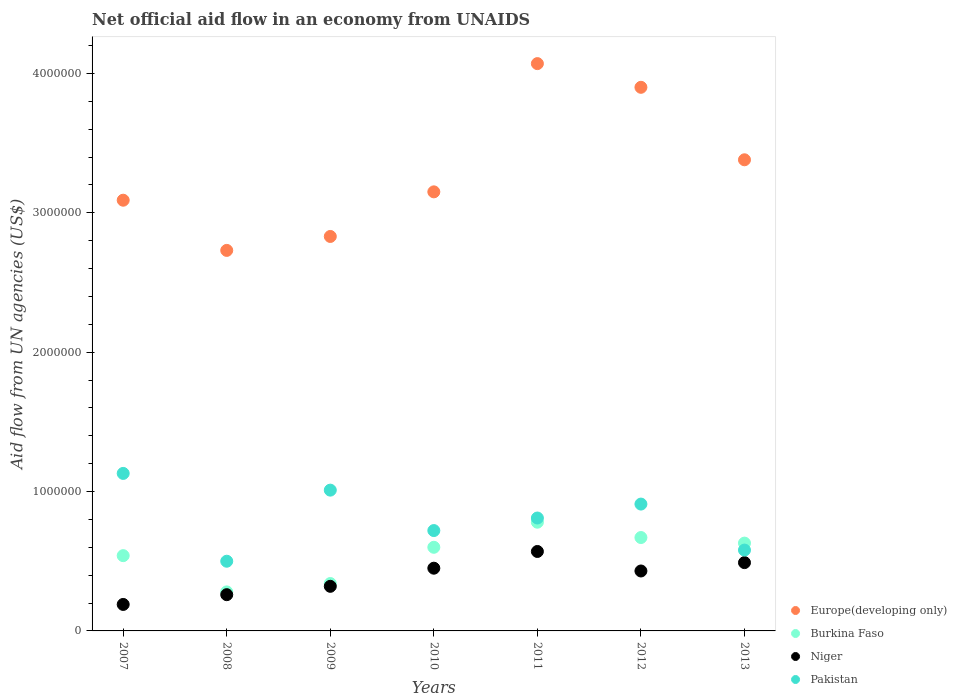What is the net official aid flow in Europe(developing only) in 2007?
Give a very brief answer. 3.09e+06. Across all years, what is the maximum net official aid flow in Europe(developing only)?
Ensure brevity in your answer.  4.07e+06. Across all years, what is the minimum net official aid flow in Niger?
Your answer should be very brief. 1.90e+05. In which year was the net official aid flow in Niger maximum?
Keep it short and to the point. 2011. What is the total net official aid flow in Niger in the graph?
Your response must be concise. 2.71e+06. What is the difference between the net official aid flow in Burkina Faso in 2008 and that in 2011?
Your answer should be compact. -5.00e+05. What is the difference between the net official aid flow in Pakistan in 2011 and the net official aid flow in Burkina Faso in 2012?
Your answer should be compact. 1.40e+05. What is the average net official aid flow in Pakistan per year?
Keep it short and to the point. 8.09e+05. In the year 2007, what is the difference between the net official aid flow in Pakistan and net official aid flow in Niger?
Give a very brief answer. 9.40e+05. What is the ratio of the net official aid flow in Pakistan in 2009 to that in 2011?
Ensure brevity in your answer.  1.25. Is the net official aid flow in Europe(developing only) in 2008 less than that in 2013?
Keep it short and to the point. Yes. What is the difference between the highest and the lowest net official aid flow in Europe(developing only)?
Give a very brief answer. 1.34e+06. In how many years, is the net official aid flow in Europe(developing only) greater than the average net official aid flow in Europe(developing only) taken over all years?
Your answer should be very brief. 3. Is it the case that in every year, the sum of the net official aid flow in Burkina Faso and net official aid flow in Pakistan  is greater than the sum of net official aid flow in Niger and net official aid flow in Europe(developing only)?
Your response must be concise. Yes. Does the net official aid flow in Pakistan monotonically increase over the years?
Provide a succinct answer. No. How many dotlines are there?
Offer a very short reply. 4. What is the difference between two consecutive major ticks on the Y-axis?
Provide a short and direct response. 1.00e+06. Does the graph contain any zero values?
Provide a succinct answer. No. Where does the legend appear in the graph?
Provide a short and direct response. Bottom right. What is the title of the graph?
Your answer should be very brief. Net official aid flow in an economy from UNAIDS. Does "South Africa" appear as one of the legend labels in the graph?
Keep it short and to the point. No. What is the label or title of the Y-axis?
Offer a terse response. Aid flow from UN agencies (US$). What is the Aid flow from UN agencies (US$) of Europe(developing only) in 2007?
Keep it short and to the point. 3.09e+06. What is the Aid flow from UN agencies (US$) of Burkina Faso in 2007?
Keep it short and to the point. 5.40e+05. What is the Aid flow from UN agencies (US$) in Pakistan in 2007?
Ensure brevity in your answer.  1.13e+06. What is the Aid flow from UN agencies (US$) in Europe(developing only) in 2008?
Provide a short and direct response. 2.73e+06. What is the Aid flow from UN agencies (US$) of Europe(developing only) in 2009?
Offer a terse response. 2.83e+06. What is the Aid flow from UN agencies (US$) in Burkina Faso in 2009?
Keep it short and to the point. 3.40e+05. What is the Aid flow from UN agencies (US$) in Niger in 2009?
Offer a terse response. 3.20e+05. What is the Aid flow from UN agencies (US$) of Pakistan in 2009?
Your answer should be very brief. 1.01e+06. What is the Aid flow from UN agencies (US$) in Europe(developing only) in 2010?
Keep it short and to the point. 3.15e+06. What is the Aid flow from UN agencies (US$) in Burkina Faso in 2010?
Your response must be concise. 6.00e+05. What is the Aid flow from UN agencies (US$) of Niger in 2010?
Make the answer very short. 4.50e+05. What is the Aid flow from UN agencies (US$) in Pakistan in 2010?
Offer a very short reply. 7.20e+05. What is the Aid flow from UN agencies (US$) in Europe(developing only) in 2011?
Your response must be concise. 4.07e+06. What is the Aid flow from UN agencies (US$) in Burkina Faso in 2011?
Make the answer very short. 7.80e+05. What is the Aid flow from UN agencies (US$) of Niger in 2011?
Provide a short and direct response. 5.70e+05. What is the Aid flow from UN agencies (US$) in Pakistan in 2011?
Your answer should be compact. 8.10e+05. What is the Aid flow from UN agencies (US$) of Europe(developing only) in 2012?
Offer a very short reply. 3.90e+06. What is the Aid flow from UN agencies (US$) in Burkina Faso in 2012?
Keep it short and to the point. 6.70e+05. What is the Aid flow from UN agencies (US$) of Niger in 2012?
Give a very brief answer. 4.30e+05. What is the Aid flow from UN agencies (US$) in Pakistan in 2012?
Offer a terse response. 9.10e+05. What is the Aid flow from UN agencies (US$) of Europe(developing only) in 2013?
Offer a terse response. 3.38e+06. What is the Aid flow from UN agencies (US$) in Burkina Faso in 2013?
Ensure brevity in your answer.  6.30e+05. What is the Aid flow from UN agencies (US$) of Pakistan in 2013?
Make the answer very short. 5.80e+05. Across all years, what is the maximum Aid flow from UN agencies (US$) in Europe(developing only)?
Keep it short and to the point. 4.07e+06. Across all years, what is the maximum Aid flow from UN agencies (US$) in Burkina Faso?
Give a very brief answer. 7.80e+05. Across all years, what is the maximum Aid flow from UN agencies (US$) in Niger?
Your response must be concise. 5.70e+05. Across all years, what is the maximum Aid flow from UN agencies (US$) of Pakistan?
Offer a very short reply. 1.13e+06. Across all years, what is the minimum Aid flow from UN agencies (US$) in Europe(developing only)?
Provide a short and direct response. 2.73e+06. Across all years, what is the minimum Aid flow from UN agencies (US$) of Niger?
Make the answer very short. 1.90e+05. Across all years, what is the minimum Aid flow from UN agencies (US$) in Pakistan?
Ensure brevity in your answer.  5.00e+05. What is the total Aid flow from UN agencies (US$) in Europe(developing only) in the graph?
Your answer should be compact. 2.32e+07. What is the total Aid flow from UN agencies (US$) in Burkina Faso in the graph?
Offer a terse response. 3.84e+06. What is the total Aid flow from UN agencies (US$) in Niger in the graph?
Your answer should be very brief. 2.71e+06. What is the total Aid flow from UN agencies (US$) in Pakistan in the graph?
Provide a succinct answer. 5.66e+06. What is the difference between the Aid flow from UN agencies (US$) of Burkina Faso in 2007 and that in 2008?
Provide a succinct answer. 2.60e+05. What is the difference between the Aid flow from UN agencies (US$) of Pakistan in 2007 and that in 2008?
Make the answer very short. 6.30e+05. What is the difference between the Aid flow from UN agencies (US$) in Europe(developing only) in 2007 and that in 2009?
Ensure brevity in your answer.  2.60e+05. What is the difference between the Aid flow from UN agencies (US$) of Niger in 2007 and that in 2009?
Give a very brief answer. -1.30e+05. What is the difference between the Aid flow from UN agencies (US$) of Pakistan in 2007 and that in 2009?
Provide a short and direct response. 1.20e+05. What is the difference between the Aid flow from UN agencies (US$) of Europe(developing only) in 2007 and that in 2010?
Offer a very short reply. -6.00e+04. What is the difference between the Aid flow from UN agencies (US$) in Burkina Faso in 2007 and that in 2010?
Make the answer very short. -6.00e+04. What is the difference between the Aid flow from UN agencies (US$) of Europe(developing only) in 2007 and that in 2011?
Offer a very short reply. -9.80e+05. What is the difference between the Aid flow from UN agencies (US$) in Niger in 2007 and that in 2011?
Provide a succinct answer. -3.80e+05. What is the difference between the Aid flow from UN agencies (US$) in Europe(developing only) in 2007 and that in 2012?
Give a very brief answer. -8.10e+05. What is the difference between the Aid flow from UN agencies (US$) in Niger in 2007 and that in 2012?
Make the answer very short. -2.40e+05. What is the difference between the Aid flow from UN agencies (US$) in Pakistan in 2007 and that in 2012?
Ensure brevity in your answer.  2.20e+05. What is the difference between the Aid flow from UN agencies (US$) in Europe(developing only) in 2007 and that in 2013?
Ensure brevity in your answer.  -2.90e+05. What is the difference between the Aid flow from UN agencies (US$) of Pakistan in 2007 and that in 2013?
Provide a succinct answer. 5.50e+05. What is the difference between the Aid flow from UN agencies (US$) in Europe(developing only) in 2008 and that in 2009?
Ensure brevity in your answer.  -1.00e+05. What is the difference between the Aid flow from UN agencies (US$) in Pakistan in 2008 and that in 2009?
Ensure brevity in your answer.  -5.10e+05. What is the difference between the Aid flow from UN agencies (US$) in Europe(developing only) in 2008 and that in 2010?
Your answer should be very brief. -4.20e+05. What is the difference between the Aid flow from UN agencies (US$) in Burkina Faso in 2008 and that in 2010?
Make the answer very short. -3.20e+05. What is the difference between the Aid flow from UN agencies (US$) of Europe(developing only) in 2008 and that in 2011?
Offer a terse response. -1.34e+06. What is the difference between the Aid flow from UN agencies (US$) in Burkina Faso in 2008 and that in 2011?
Offer a very short reply. -5.00e+05. What is the difference between the Aid flow from UN agencies (US$) in Niger in 2008 and that in 2011?
Offer a very short reply. -3.10e+05. What is the difference between the Aid flow from UN agencies (US$) in Pakistan in 2008 and that in 2011?
Make the answer very short. -3.10e+05. What is the difference between the Aid flow from UN agencies (US$) in Europe(developing only) in 2008 and that in 2012?
Provide a short and direct response. -1.17e+06. What is the difference between the Aid flow from UN agencies (US$) in Burkina Faso in 2008 and that in 2012?
Keep it short and to the point. -3.90e+05. What is the difference between the Aid flow from UN agencies (US$) in Niger in 2008 and that in 2012?
Your response must be concise. -1.70e+05. What is the difference between the Aid flow from UN agencies (US$) of Pakistan in 2008 and that in 2012?
Offer a very short reply. -4.10e+05. What is the difference between the Aid flow from UN agencies (US$) of Europe(developing only) in 2008 and that in 2013?
Provide a short and direct response. -6.50e+05. What is the difference between the Aid flow from UN agencies (US$) of Burkina Faso in 2008 and that in 2013?
Your answer should be compact. -3.50e+05. What is the difference between the Aid flow from UN agencies (US$) in Pakistan in 2008 and that in 2013?
Give a very brief answer. -8.00e+04. What is the difference between the Aid flow from UN agencies (US$) in Europe(developing only) in 2009 and that in 2010?
Your response must be concise. -3.20e+05. What is the difference between the Aid flow from UN agencies (US$) of Burkina Faso in 2009 and that in 2010?
Offer a very short reply. -2.60e+05. What is the difference between the Aid flow from UN agencies (US$) of Niger in 2009 and that in 2010?
Make the answer very short. -1.30e+05. What is the difference between the Aid flow from UN agencies (US$) in Pakistan in 2009 and that in 2010?
Ensure brevity in your answer.  2.90e+05. What is the difference between the Aid flow from UN agencies (US$) in Europe(developing only) in 2009 and that in 2011?
Make the answer very short. -1.24e+06. What is the difference between the Aid flow from UN agencies (US$) of Burkina Faso in 2009 and that in 2011?
Your answer should be very brief. -4.40e+05. What is the difference between the Aid flow from UN agencies (US$) of Europe(developing only) in 2009 and that in 2012?
Offer a very short reply. -1.07e+06. What is the difference between the Aid flow from UN agencies (US$) of Burkina Faso in 2009 and that in 2012?
Your answer should be compact. -3.30e+05. What is the difference between the Aid flow from UN agencies (US$) of Pakistan in 2009 and that in 2012?
Ensure brevity in your answer.  1.00e+05. What is the difference between the Aid flow from UN agencies (US$) of Europe(developing only) in 2009 and that in 2013?
Provide a succinct answer. -5.50e+05. What is the difference between the Aid flow from UN agencies (US$) of Burkina Faso in 2009 and that in 2013?
Your response must be concise. -2.90e+05. What is the difference between the Aid flow from UN agencies (US$) in Europe(developing only) in 2010 and that in 2011?
Offer a very short reply. -9.20e+05. What is the difference between the Aid flow from UN agencies (US$) of Pakistan in 2010 and that in 2011?
Give a very brief answer. -9.00e+04. What is the difference between the Aid flow from UN agencies (US$) of Europe(developing only) in 2010 and that in 2012?
Make the answer very short. -7.50e+05. What is the difference between the Aid flow from UN agencies (US$) in Burkina Faso in 2010 and that in 2012?
Keep it short and to the point. -7.00e+04. What is the difference between the Aid flow from UN agencies (US$) in Niger in 2010 and that in 2012?
Offer a terse response. 2.00e+04. What is the difference between the Aid flow from UN agencies (US$) in Niger in 2010 and that in 2013?
Offer a terse response. -4.00e+04. What is the difference between the Aid flow from UN agencies (US$) of Pakistan in 2010 and that in 2013?
Make the answer very short. 1.40e+05. What is the difference between the Aid flow from UN agencies (US$) of Burkina Faso in 2011 and that in 2012?
Offer a very short reply. 1.10e+05. What is the difference between the Aid flow from UN agencies (US$) in Niger in 2011 and that in 2012?
Keep it short and to the point. 1.40e+05. What is the difference between the Aid flow from UN agencies (US$) in Europe(developing only) in 2011 and that in 2013?
Keep it short and to the point. 6.90e+05. What is the difference between the Aid flow from UN agencies (US$) of Burkina Faso in 2011 and that in 2013?
Your response must be concise. 1.50e+05. What is the difference between the Aid flow from UN agencies (US$) of Pakistan in 2011 and that in 2013?
Your answer should be compact. 2.30e+05. What is the difference between the Aid flow from UN agencies (US$) of Europe(developing only) in 2012 and that in 2013?
Offer a terse response. 5.20e+05. What is the difference between the Aid flow from UN agencies (US$) of Burkina Faso in 2012 and that in 2013?
Keep it short and to the point. 4.00e+04. What is the difference between the Aid flow from UN agencies (US$) of Niger in 2012 and that in 2013?
Your answer should be very brief. -6.00e+04. What is the difference between the Aid flow from UN agencies (US$) in Pakistan in 2012 and that in 2013?
Your response must be concise. 3.30e+05. What is the difference between the Aid flow from UN agencies (US$) of Europe(developing only) in 2007 and the Aid flow from UN agencies (US$) of Burkina Faso in 2008?
Your answer should be compact. 2.81e+06. What is the difference between the Aid flow from UN agencies (US$) of Europe(developing only) in 2007 and the Aid flow from UN agencies (US$) of Niger in 2008?
Provide a short and direct response. 2.83e+06. What is the difference between the Aid flow from UN agencies (US$) in Europe(developing only) in 2007 and the Aid flow from UN agencies (US$) in Pakistan in 2008?
Offer a terse response. 2.59e+06. What is the difference between the Aid flow from UN agencies (US$) of Burkina Faso in 2007 and the Aid flow from UN agencies (US$) of Niger in 2008?
Your response must be concise. 2.80e+05. What is the difference between the Aid flow from UN agencies (US$) in Burkina Faso in 2007 and the Aid flow from UN agencies (US$) in Pakistan in 2008?
Give a very brief answer. 4.00e+04. What is the difference between the Aid flow from UN agencies (US$) in Niger in 2007 and the Aid flow from UN agencies (US$) in Pakistan in 2008?
Keep it short and to the point. -3.10e+05. What is the difference between the Aid flow from UN agencies (US$) in Europe(developing only) in 2007 and the Aid flow from UN agencies (US$) in Burkina Faso in 2009?
Your answer should be compact. 2.75e+06. What is the difference between the Aid flow from UN agencies (US$) in Europe(developing only) in 2007 and the Aid flow from UN agencies (US$) in Niger in 2009?
Provide a short and direct response. 2.77e+06. What is the difference between the Aid flow from UN agencies (US$) of Europe(developing only) in 2007 and the Aid flow from UN agencies (US$) of Pakistan in 2009?
Offer a very short reply. 2.08e+06. What is the difference between the Aid flow from UN agencies (US$) of Burkina Faso in 2007 and the Aid flow from UN agencies (US$) of Pakistan in 2009?
Offer a terse response. -4.70e+05. What is the difference between the Aid flow from UN agencies (US$) in Niger in 2007 and the Aid flow from UN agencies (US$) in Pakistan in 2009?
Provide a short and direct response. -8.20e+05. What is the difference between the Aid flow from UN agencies (US$) of Europe(developing only) in 2007 and the Aid flow from UN agencies (US$) of Burkina Faso in 2010?
Make the answer very short. 2.49e+06. What is the difference between the Aid flow from UN agencies (US$) of Europe(developing only) in 2007 and the Aid flow from UN agencies (US$) of Niger in 2010?
Your answer should be very brief. 2.64e+06. What is the difference between the Aid flow from UN agencies (US$) in Europe(developing only) in 2007 and the Aid flow from UN agencies (US$) in Pakistan in 2010?
Offer a terse response. 2.37e+06. What is the difference between the Aid flow from UN agencies (US$) of Burkina Faso in 2007 and the Aid flow from UN agencies (US$) of Pakistan in 2010?
Your answer should be very brief. -1.80e+05. What is the difference between the Aid flow from UN agencies (US$) of Niger in 2007 and the Aid flow from UN agencies (US$) of Pakistan in 2010?
Make the answer very short. -5.30e+05. What is the difference between the Aid flow from UN agencies (US$) of Europe(developing only) in 2007 and the Aid flow from UN agencies (US$) of Burkina Faso in 2011?
Ensure brevity in your answer.  2.31e+06. What is the difference between the Aid flow from UN agencies (US$) in Europe(developing only) in 2007 and the Aid flow from UN agencies (US$) in Niger in 2011?
Give a very brief answer. 2.52e+06. What is the difference between the Aid flow from UN agencies (US$) of Europe(developing only) in 2007 and the Aid flow from UN agencies (US$) of Pakistan in 2011?
Offer a very short reply. 2.28e+06. What is the difference between the Aid flow from UN agencies (US$) in Burkina Faso in 2007 and the Aid flow from UN agencies (US$) in Pakistan in 2011?
Your answer should be compact. -2.70e+05. What is the difference between the Aid flow from UN agencies (US$) of Niger in 2007 and the Aid flow from UN agencies (US$) of Pakistan in 2011?
Keep it short and to the point. -6.20e+05. What is the difference between the Aid flow from UN agencies (US$) in Europe(developing only) in 2007 and the Aid flow from UN agencies (US$) in Burkina Faso in 2012?
Provide a short and direct response. 2.42e+06. What is the difference between the Aid flow from UN agencies (US$) in Europe(developing only) in 2007 and the Aid flow from UN agencies (US$) in Niger in 2012?
Your answer should be compact. 2.66e+06. What is the difference between the Aid flow from UN agencies (US$) of Europe(developing only) in 2007 and the Aid flow from UN agencies (US$) of Pakistan in 2012?
Provide a short and direct response. 2.18e+06. What is the difference between the Aid flow from UN agencies (US$) of Burkina Faso in 2007 and the Aid flow from UN agencies (US$) of Niger in 2012?
Your response must be concise. 1.10e+05. What is the difference between the Aid flow from UN agencies (US$) in Burkina Faso in 2007 and the Aid flow from UN agencies (US$) in Pakistan in 2012?
Offer a terse response. -3.70e+05. What is the difference between the Aid flow from UN agencies (US$) in Niger in 2007 and the Aid flow from UN agencies (US$) in Pakistan in 2012?
Your response must be concise. -7.20e+05. What is the difference between the Aid flow from UN agencies (US$) in Europe(developing only) in 2007 and the Aid flow from UN agencies (US$) in Burkina Faso in 2013?
Provide a short and direct response. 2.46e+06. What is the difference between the Aid flow from UN agencies (US$) of Europe(developing only) in 2007 and the Aid flow from UN agencies (US$) of Niger in 2013?
Provide a short and direct response. 2.60e+06. What is the difference between the Aid flow from UN agencies (US$) in Europe(developing only) in 2007 and the Aid flow from UN agencies (US$) in Pakistan in 2013?
Offer a very short reply. 2.51e+06. What is the difference between the Aid flow from UN agencies (US$) of Burkina Faso in 2007 and the Aid flow from UN agencies (US$) of Pakistan in 2013?
Provide a succinct answer. -4.00e+04. What is the difference between the Aid flow from UN agencies (US$) in Niger in 2007 and the Aid flow from UN agencies (US$) in Pakistan in 2013?
Your answer should be compact. -3.90e+05. What is the difference between the Aid flow from UN agencies (US$) in Europe(developing only) in 2008 and the Aid flow from UN agencies (US$) in Burkina Faso in 2009?
Your answer should be very brief. 2.39e+06. What is the difference between the Aid flow from UN agencies (US$) of Europe(developing only) in 2008 and the Aid flow from UN agencies (US$) of Niger in 2009?
Offer a terse response. 2.41e+06. What is the difference between the Aid flow from UN agencies (US$) of Europe(developing only) in 2008 and the Aid flow from UN agencies (US$) of Pakistan in 2009?
Offer a very short reply. 1.72e+06. What is the difference between the Aid flow from UN agencies (US$) of Burkina Faso in 2008 and the Aid flow from UN agencies (US$) of Pakistan in 2009?
Ensure brevity in your answer.  -7.30e+05. What is the difference between the Aid flow from UN agencies (US$) in Niger in 2008 and the Aid flow from UN agencies (US$) in Pakistan in 2009?
Ensure brevity in your answer.  -7.50e+05. What is the difference between the Aid flow from UN agencies (US$) in Europe(developing only) in 2008 and the Aid flow from UN agencies (US$) in Burkina Faso in 2010?
Make the answer very short. 2.13e+06. What is the difference between the Aid flow from UN agencies (US$) of Europe(developing only) in 2008 and the Aid flow from UN agencies (US$) of Niger in 2010?
Provide a short and direct response. 2.28e+06. What is the difference between the Aid flow from UN agencies (US$) in Europe(developing only) in 2008 and the Aid flow from UN agencies (US$) in Pakistan in 2010?
Your response must be concise. 2.01e+06. What is the difference between the Aid flow from UN agencies (US$) of Burkina Faso in 2008 and the Aid flow from UN agencies (US$) of Niger in 2010?
Provide a short and direct response. -1.70e+05. What is the difference between the Aid flow from UN agencies (US$) in Burkina Faso in 2008 and the Aid flow from UN agencies (US$) in Pakistan in 2010?
Offer a very short reply. -4.40e+05. What is the difference between the Aid flow from UN agencies (US$) in Niger in 2008 and the Aid flow from UN agencies (US$) in Pakistan in 2010?
Your answer should be compact. -4.60e+05. What is the difference between the Aid flow from UN agencies (US$) of Europe(developing only) in 2008 and the Aid flow from UN agencies (US$) of Burkina Faso in 2011?
Make the answer very short. 1.95e+06. What is the difference between the Aid flow from UN agencies (US$) of Europe(developing only) in 2008 and the Aid flow from UN agencies (US$) of Niger in 2011?
Keep it short and to the point. 2.16e+06. What is the difference between the Aid flow from UN agencies (US$) in Europe(developing only) in 2008 and the Aid flow from UN agencies (US$) in Pakistan in 2011?
Ensure brevity in your answer.  1.92e+06. What is the difference between the Aid flow from UN agencies (US$) in Burkina Faso in 2008 and the Aid flow from UN agencies (US$) in Niger in 2011?
Make the answer very short. -2.90e+05. What is the difference between the Aid flow from UN agencies (US$) in Burkina Faso in 2008 and the Aid flow from UN agencies (US$) in Pakistan in 2011?
Offer a very short reply. -5.30e+05. What is the difference between the Aid flow from UN agencies (US$) of Niger in 2008 and the Aid flow from UN agencies (US$) of Pakistan in 2011?
Offer a very short reply. -5.50e+05. What is the difference between the Aid flow from UN agencies (US$) in Europe(developing only) in 2008 and the Aid flow from UN agencies (US$) in Burkina Faso in 2012?
Your answer should be compact. 2.06e+06. What is the difference between the Aid flow from UN agencies (US$) of Europe(developing only) in 2008 and the Aid flow from UN agencies (US$) of Niger in 2012?
Your response must be concise. 2.30e+06. What is the difference between the Aid flow from UN agencies (US$) of Europe(developing only) in 2008 and the Aid flow from UN agencies (US$) of Pakistan in 2012?
Provide a succinct answer. 1.82e+06. What is the difference between the Aid flow from UN agencies (US$) in Burkina Faso in 2008 and the Aid flow from UN agencies (US$) in Niger in 2012?
Provide a succinct answer. -1.50e+05. What is the difference between the Aid flow from UN agencies (US$) of Burkina Faso in 2008 and the Aid flow from UN agencies (US$) of Pakistan in 2012?
Your answer should be very brief. -6.30e+05. What is the difference between the Aid flow from UN agencies (US$) of Niger in 2008 and the Aid flow from UN agencies (US$) of Pakistan in 2012?
Provide a short and direct response. -6.50e+05. What is the difference between the Aid flow from UN agencies (US$) in Europe(developing only) in 2008 and the Aid flow from UN agencies (US$) in Burkina Faso in 2013?
Ensure brevity in your answer.  2.10e+06. What is the difference between the Aid flow from UN agencies (US$) in Europe(developing only) in 2008 and the Aid flow from UN agencies (US$) in Niger in 2013?
Make the answer very short. 2.24e+06. What is the difference between the Aid flow from UN agencies (US$) in Europe(developing only) in 2008 and the Aid flow from UN agencies (US$) in Pakistan in 2013?
Provide a succinct answer. 2.15e+06. What is the difference between the Aid flow from UN agencies (US$) in Niger in 2008 and the Aid flow from UN agencies (US$) in Pakistan in 2013?
Provide a short and direct response. -3.20e+05. What is the difference between the Aid flow from UN agencies (US$) of Europe(developing only) in 2009 and the Aid flow from UN agencies (US$) of Burkina Faso in 2010?
Make the answer very short. 2.23e+06. What is the difference between the Aid flow from UN agencies (US$) in Europe(developing only) in 2009 and the Aid flow from UN agencies (US$) in Niger in 2010?
Provide a succinct answer. 2.38e+06. What is the difference between the Aid flow from UN agencies (US$) of Europe(developing only) in 2009 and the Aid flow from UN agencies (US$) of Pakistan in 2010?
Give a very brief answer. 2.11e+06. What is the difference between the Aid flow from UN agencies (US$) in Burkina Faso in 2009 and the Aid flow from UN agencies (US$) in Pakistan in 2010?
Your response must be concise. -3.80e+05. What is the difference between the Aid flow from UN agencies (US$) of Niger in 2009 and the Aid flow from UN agencies (US$) of Pakistan in 2010?
Your response must be concise. -4.00e+05. What is the difference between the Aid flow from UN agencies (US$) in Europe(developing only) in 2009 and the Aid flow from UN agencies (US$) in Burkina Faso in 2011?
Offer a terse response. 2.05e+06. What is the difference between the Aid flow from UN agencies (US$) of Europe(developing only) in 2009 and the Aid flow from UN agencies (US$) of Niger in 2011?
Ensure brevity in your answer.  2.26e+06. What is the difference between the Aid flow from UN agencies (US$) in Europe(developing only) in 2009 and the Aid flow from UN agencies (US$) in Pakistan in 2011?
Offer a very short reply. 2.02e+06. What is the difference between the Aid flow from UN agencies (US$) in Burkina Faso in 2009 and the Aid flow from UN agencies (US$) in Niger in 2011?
Your answer should be compact. -2.30e+05. What is the difference between the Aid flow from UN agencies (US$) of Burkina Faso in 2009 and the Aid flow from UN agencies (US$) of Pakistan in 2011?
Your response must be concise. -4.70e+05. What is the difference between the Aid flow from UN agencies (US$) of Niger in 2009 and the Aid flow from UN agencies (US$) of Pakistan in 2011?
Provide a short and direct response. -4.90e+05. What is the difference between the Aid flow from UN agencies (US$) of Europe(developing only) in 2009 and the Aid flow from UN agencies (US$) of Burkina Faso in 2012?
Keep it short and to the point. 2.16e+06. What is the difference between the Aid flow from UN agencies (US$) of Europe(developing only) in 2009 and the Aid flow from UN agencies (US$) of Niger in 2012?
Make the answer very short. 2.40e+06. What is the difference between the Aid flow from UN agencies (US$) of Europe(developing only) in 2009 and the Aid flow from UN agencies (US$) of Pakistan in 2012?
Your answer should be compact. 1.92e+06. What is the difference between the Aid flow from UN agencies (US$) of Burkina Faso in 2009 and the Aid flow from UN agencies (US$) of Pakistan in 2012?
Provide a succinct answer. -5.70e+05. What is the difference between the Aid flow from UN agencies (US$) in Niger in 2009 and the Aid flow from UN agencies (US$) in Pakistan in 2012?
Give a very brief answer. -5.90e+05. What is the difference between the Aid flow from UN agencies (US$) in Europe(developing only) in 2009 and the Aid flow from UN agencies (US$) in Burkina Faso in 2013?
Give a very brief answer. 2.20e+06. What is the difference between the Aid flow from UN agencies (US$) of Europe(developing only) in 2009 and the Aid flow from UN agencies (US$) of Niger in 2013?
Make the answer very short. 2.34e+06. What is the difference between the Aid flow from UN agencies (US$) of Europe(developing only) in 2009 and the Aid flow from UN agencies (US$) of Pakistan in 2013?
Provide a succinct answer. 2.25e+06. What is the difference between the Aid flow from UN agencies (US$) in Niger in 2009 and the Aid flow from UN agencies (US$) in Pakistan in 2013?
Offer a very short reply. -2.60e+05. What is the difference between the Aid flow from UN agencies (US$) of Europe(developing only) in 2010 and the Aid flow from UN agencies (US$) of Burkina Faso in 2011?
Offer a terse response. 2.37e+06. What is the difference between the Aid flow from UN agencies (US$) in Europe(developing only) in 2010 and the Aid flow from UN agencies (US$) in Niger in 2011?
Make the answer very short. 2.58e+06. What is the difference between the Aid flow from UN agencies (US$) in Europe(developing only) in 2010 and the Aid flow from UN agencies (US$) in Pakistan in 2011?
Your answer should be very brief. 2.34e+06. What is the difference between the Aid flow from UN agencies (US$) in Burkina Faso in 2010 and the Aid flow from UN agencies (US$) in Pakistan in 2011?
Offer a terse response. -2.10e+05. What is the difference between the Aid flow from UN agencies (US$) of Niger in 2010 and the Aid flow from UN agencies (US$) of Pakistan in 2011?
Provide a succinct answer. -3.60e+05. What is the difference between the Aid flow from UN agencies (US$) of Europe(developing only) in 2010 and the Aid flow from UN agencies (US$) of Burkina Faso in 2012?
Your response must be concise. 2.48e+06. What is the difference between the Aid flow from UN agencies (US$) in Europe(developing only) in 2010 and the Aid flow from UN agencies (US$) in Niger in 2012?
Make the answer very short. 2.72e+06. What is the difference between the Aid flow from UN agencies (US$) of Europe(developing only) in 2010 and the Aid flow from UN agencies (US$) of Pakistan in 2012?
Provide a succinct answer. 2.24e+06. What is the difference between the Aid flow from UN agencies (US$) in Burkina Faso in 2010 and the Aid flow from UN agencies (US$) in Pakistan in 2012?
Your answer should be very brief. -3.10e+05. What is the difference between the Aid flow from UN agencies (US$) of Niger in 2010 and the Aid flow from UN agencies (US$) of Pakistan in 2012?
Provide a short and direct response. -4.60e+05. What is the difference between the Aid flow from UN agencies (US$) in Europe(developing only) in 2010 and the Aid flow from UN agencies (US$) in Burkina Faso in 2013?
Provide a succinct answer. 2.52e+06. What is the difference between the Aid flow from UN agencies (US$) of Europe(developing only) in 2010 and the Aid flow from UN agencies (US$) of Niger in 2013?
Provide a short and direct response. 2.66e+06. What is the difference between the Aid flow from UN agencies (US$) of Europe(developing only) in 2010 and the Aid flow from UN agencies (US$) of Pakistan in 2013?
Offer a terse response. 2.57e+06. What is the difference between the Aid flow from UN agencies (US$) of Niger in 2010 and the Aid flow from UN agencies (US$) of Pakistan in 2013?
Provide a short and direct response. -1.30e+05. What is the difference between the Aid flow from UN agencies (US$) of Europe(developing only) in 2011 and the Aid flow from UN agencies (US$) of Burkina Faso in 2012?
Keep it short and to the point. 3.40e+06. What is the difference between the Aid flow from UN agencies (US$) of Europe(developing only) in 2011 and the Aid flow from UN agencies (US$) of Niger in 2012?
Provide a succinct answer. 3.64e+06. What is the difference between the Aid flow from UN agencies (US$) in Europe(developing only) in 2011 and the Aid flow from UN agencies (US$) in Pakistan in 2012?
Make the answer very short. 3.16e+06. What is the difference between the Aid flow from UN agencies (US$) in Europe(developing only) in 2011 and the Aid flow from UN agencies (US$) in Burkina Faso in 2013?
Your response must be concise. 3.44e+06. What is the difference between the Aid flow from UN agencies (US$) of Europe(developing only) in 2011 and the Aid flow from UN agencies (US$) of Niger in 2013?
Your answer should be very brief. 3.58e+06. What is the difference between the Aid flow from UN agencies (US$) in Europe(developing only) in 2011 and the Aid flow from UN agencies (US$) in Pakistan in 2013?
Your answer should be compact. 3.49e+06. What is the difference between the Aid flow from UN agencies (US$) in Europe(developing only) in 2012 and the Aid flow from UN agencies (US$) in Burkina Faso in 2013?
Keep it short and to the point. 3.27e+06. What is the difference between the Aid flow from UN agencies (US$) of Europe(developing only) in 2012 and the Aid flow from UN agencies (US$) of Niger in 2013?
Provide a short and direct response. 3.41e+06. What is the difference between the Aid flow from UN agencies (US$) of Europe(developing only) in 2012 and the Aid flow from UN agencies (US$) of Pakistan in 2013?
Offer a terse response. 3.32e+06. What is the difference between the Aid flow from UN agencies (US$) of Burkina Faso in 2012 and the Aid flow from UN agencies (US$) of Niger in 2013?
Make the answer very short. 1.80e+05. What is the average Aid flow from UN agencies (US$) in Europe(developing only) per year?
Provide a succinct answer. 3.31e+06. What is the average Aid flow from UN agencies (US$) of Burkina Faso per year?
Ensure brevity in your answer.  5.49e+05. What is the average Aid flow from UN agencies (US$) in Niger per year?
Your answer should be compact. 3.87e+05. What is the average Aid flow from UN agencies (US$) in Pakistan per year?
Make the answer very short. 8.09e+05. In the year 2007, what is the difference between the Aid flow from UN agencies (US$) in Europe(developing only) and Aid flow from UN agencies (US$) in Burkina Faso?
Keep it short and to the point. 2.55e+06. In the year 2007, what is the difference between the Aid flow from UN agencies (US$) of Europe(developing only) and Aid flow from UN agencies (US$) of Niger?
Offer a terse response. 2.90e+06. In the year 2007, what is the difference between the Aid flow from UN agencies (US$) of Europe(developing only) and Aid flow from UN agencies (US$) of Pakistan?
Provide a succinct answer. 1.96e+06. In the year 2007, what is the difference between the Aid flow from UN agencies (US$) in Burkina Faso and Aid flow from UN agencies (US$) in Niger?
Offer a very short reply. 3.50e+05. In the year 2007, what is the difference between the Aid flow from UN agencies (US$) in Burkina Faso and Aid flow from UN agencies (US$) in Pakistan?
Keep it short and to the point. -5.90e+05. In the year 2007, what is the difference between the Aid flow from UN agencies (US$) of Niger and Aid flow from UN agencies (US$) of Pakistan?
Offer a very short reply. -9.40e+05. In the year 2008, what is the difference between the Aid flow from UN agencies (US$) of Europe(developing only) and Aid flow from UN agencies (US$) of Burkina Faso?
Offer a very short reply. 2.45e+06. In the year 2008, what is the difference between the Aid flow from UN agencies (US$) in Europe(developing only) and Aid flow from UN agencies (US$) in Niger?
Your response must be concise. 2.47e+06. In the year 2008, what is the difference between the Aid flow from UN agencies (US$) of Europe(developing only) and Aid flow from UN agencies (US$) of Pakistan?
Offer a terse response. 2.23e+06. In the year 2008, what is the difference between the Aid flow from UN agencies (US$) in Burkina Faso and Aid flow from UN agencies (US$) in Niger?
Give a very brief answer. 2.00e+04. In the year 2008, what is the difference between the Aid flow from UN agencies (US$) of Niger and Aid flow from UN agencies (US$) of Pakistan?
Your answer should be very brief. -2.40e+05. In the year 2009, what is the difference between the Aid flow from UN agencies (US$) of Europe(developing only) and Aid flow from UN agencies (US$) of Burkina Faso?
Your answer should be compact. 2.49e+06. In the year 2009, what is the difference between the Aid flow from UN agencies (US$) in Europe(developing only) and Aid flow from UN agencies (US$) in Niger?
Provide a short and direct response. 2.51e+06. In the year 2009, what is the difference between the Aid flow from UN agencies (US$) of Europe(developing only) and Aid flow from UN agencies (US$) of Pakistan?
Offer a very short reply. 1.82e+06. In the year 2009, what is the difference between the Aid flow from UN agencies (US$) in Burkina Faso and Aid flow from UN agencies (US$) in Niger?
Your answer should be very brief. 2.00e+04. In the year 2009, what is the difference between the Aid flow from UN agencies (US$) of Burkina Faso and Aid flow from UN agencies (US$) of Pakistan?
Provide a succinct answer. -6.70e+05. In the year 2009, what is the difference between the Aid flow from UN agencies (US$) in Niger and Aid flow from UN agencies (US$) in Pakistan?
Provide a short and direct response. -6.90e+05. In the year 2010, what is the difference between the Aid flow from UN agencies (US$) in Europe(developing only) and Aid flow from UN agencies (US$) in Burkina Faso?
Ensure brevity in your answer.  2.55e+06. In the year 2010, what is the difference between the Aid flow from UN agencies (US$) of Europe(developing only) and Aid flow from UN agencies (US$) of Niger?
Keep it short and to the point. 2.70e+06. In the year 2010, what is the difference between the Aid flow from UN agencies (US$) of Europe(developing only) and Aid flow from UN agencies (US$) of Pakistan?
Ensure brevity in your answer.  2.43e+06. In the year 2010, what is the difference between the Aid flow from UN agencies (US$) in Burkina Faso and Aid flow from UN agencies (US$) in Niger?
Give a very brief answer. 1.50e+05. In the year 2010, what is the difference between the Aid flow from UN agencies (US$) of Niger and Aid flow from UN agencies (US$) of Pakistan?
Provide a short and direct response. -2.70e+05. In the year 2011, what is the difference between the Aid flow from UN agencies (US$) in Europe(developing only) and Aid flow from UN agencies (US$) in Burkina Faso?
Ensure brevity in your answer.  3.29e+06. In the year 2011, what is the difference between the Aid flow from UN agencies (US$) in Europe(developing only) and Aid flow from UN agencies (US$) in Niger?
Provide a short and direct response. 3.50e+06. In the year 2011, what is the difference between the Aid flow from UN agencies (US$) of Europe(developing only) and Aid flow from UN agencies (US$) of Pakistan?
Ensure brevity in your answer.  3.26e+06. In the year 2011, what is the difference between the Aid flow from UN agencies (US$) of Burkina Faso and Aid flow from UN agencies (US$) of Niger?
Keep it short and to the point. 2.10e+05. In the year 2011, what is the difference between the Aid flow from UN agencies (US$) in Burkina Faso and Aid flow from UN agencies (US$) in Pakistan?
Make the answer very short. -3.00e+04. In the year 2011, what is the difference between the Aid flow from UN agencies (US$) in Niger and Aid flow from UN agencies (US$) in Pakistan?
Ensure brevity in your answer.  -2.40e+05. In the year 2012, what is the difference between the Aid flow from UN agencies (US$) of Europe(developing only) and Aid flow from UN agencies (US$) of Burkina Faso?
Give a very brief answer. 3.23e+06. In the year 2012, what is the difference between the Aid flow from UN agencies (US$) of Europe(developing only) and Aid flow from UN agencies (US$) of Niger?
Your response must be concise. 3.47e+06. In the year 2012, what is the difference between the Aid flow from UN agencies (US$) in Europe(developing only) and Aid flow from UN agencies (US$) in Pakistan?
Ensure brevity in your answer.  2.99e+06. In the year 2012, what is the difference between the Aid flow from UN agencies (US$) of Burkina Faso and Aid flow from UN agencies (US$) of Pakistan?
Ensure brevity in your answer.  -2.40e+05. In the year 2012, what is the difference between the Aid flow from UN agencies (US$) in Niger and Aid flow from UN agencies (US$) in Pakistan?
Your answer should be compact. -4.80e+05. In the year 2013, what is the difference between the Aid flow from UN agencies (US$) in Europe(developing only) and Aid flow from UN agencies (US$) in Burkina Faso?
Keep it short and to the point. 2.75e+06. In the year 2013, what is the difference between the Aid flow from UN agencies (US$) of Europe(developing only) and Aid flow from UN agencies (US$) of Niger?
Make the answer very short. 2.89e+06. In the year 2013, what is the difference between the Aid flow from UN agencies (US$) in Europe(developing only) and Aid flow from UN agencies (US$) in Pakistan?
Ensure brevity in your answer.  2.80e+06. In the year 2013, what is the difference between the Aid flow from UN agencies (US$) in Niger and Aid flow from UN agencies (US$) in Pakistan?
Keep it short and to the point. -9.00e+04. What is the ratio of the Aid flow from UN agencies (US$) of Europe(developing only) in 2007 to that in 2008?
Make the answer very short. 1.13. What is the ratio of the Aid flow from UN agencies (US$) in Burkina Faso in 2007 to that in 2008?
Provide a succinct answer. 1.93. What is the ratio of the Aid flow from UN agencies (US$) of Niger in 2007 to that in 2008?
Provide a succinct answer. 0.73. What is the ratio of the Aid flow from UN agencies (US$) of Pakistan in 2007 to that in 2008?
Provide a succinct answer. 2.26. What is the ratio of the Aid flow from UN agencies (US$) of Europe(developing only) in 2007 to that in 2009?
Your answer should be very brief. 1.09. What is the ratio of the Aid flow from UN agencies (US$) of Burkina Faso in 2007 to that in 2009?
Your answer should be very brief. 1.59. What is the ratio of the Aid flow from UN agencies (US$) of Niger in 2007 to that in 2009?
Make the answer very short. 0.59. What is the ratio of the Aid flow from UN agencies (US$) of Pakistan in 2007 to that in 2009?
Make the answer very short. 1.12. What is the ratio of the Aid flow from UN agencies (US$) of Burkina Faso in 2007 to that in 2010?
Provide a succinct answer. 0.9. What is the ratio of the Aid flow from UN agencies (US$) of Niger in 2007 to that in 2010?
Make the answer very short. 0.42. What is the ratio of the Aid flow from UN agencies (US$) in Pakistan in 2007 to that in 2010?
Your answer should be very brief. 1.57. What is the ratio of the Aid flow from UN agencies (US$) of Europe(developing only) in 2007 to that in 2011?
Provide a succinct answer. 0.76. What is the ratio of the Aid flow from UN agencies (US$) of Burkina Faso in 2007 to that in 2011?
Make the answer very short. 0.69. What is the ratio of the Aid flow from UN agencies (US$) of Pakistan in 2007 to that in 2011?
Your answer should be very brief. 1.4. What is the ratio of the Aid flow from UN agencies (US$) of Europe(developing only) in 2007 to that in 2012?
Offer a very short reply. 0.79. What is the ratio of the Aid flow from UN agencies (US$) of Burkina Faso in 2007 to that in 2012?
Your answer should be compact. 0.81. What is the ratio of the Aid flow from UN agencies (US$) in Niger in 2007 to that in 2012?
Provide a succinct answer. 0.44. What is the ratio of the Aid flow from UN agencies (US$) of Pakistan in 2007 to that in 2012?
Make the answer very short. 1.24. What is the ratio of the Aid flow from UN agencies (US$) in Europe(developing only) in 2007 to that in 2013?
Ensure brevity in your answer.  0.91. What is the ratio of the Aid flow from UN agencies (US$) of Niger in 2007 to that in 2013?
Your response must be concise. 0.39. What is the ratio of the Aid flow from UN agencies (US$) of Pakistan in 2007 to that in 2013?
Provide a succinct answer. 1.95. What is the ratio of the Aid flow from UN agencies (US$) of Europe(developing only) in 2008 to that in 2009?
Provide a short and direct response. 0.96. What is the ratio of the Aid flow from UN agencies (US$) in Burkina Faso in 2008 to that in 2009?
Keep it short and to the point. 0.82. What is the ratio of the Aid flow from UN agencies (US$) in Niger in 2008 to that in 2009?
Your answer should be compact. 0.81. What is the ratio of the Aid flow from UN agencies (US$) of Pakistan in 2008 to that in 2009?
Provide a succinct answer. 0.49. What is the ratio of the Aid flow from UN agencies (US$) of Europe(developing only) in 2008 to that in 2010?
Give a very brief answer. 0.87. What is the ratio of the Aid flow from UN agencies (US$) of Burkina Faso in 2008 to that in 2010?
Offer a terse response. 0.47. What is the ratio of the Aid flow from UN agencies (US$) in Niger in 2008 to that in 2010?
Provide a succinct answer. 0.58. What is the ratio of the Aid flow from UN agencies (US$) in Pakistan in 2008 to that in 2010?
Offer a very short reply. 0.69. What is the ratio of the Aid flow from UN agencies (US$) in Europe(developing only) in 2008 to that in 2011?
Your response must be concise. 0.67. What is the ratio of the Aid flow from UN agencies (US$) of Burkina Faso in 2008 to that in 2011?
Offer a very short reply. 0.36. What is the ratio of the Aid flow from UN agencies (US$) of Niger in 2008 to that in 2011?
Offer a terse response. 0.46. What is the ratio of the Aid flow from UN agencies (US$) in Pakistan in 2008 to that in 2011?
Your response must be concise. 0.62. What is the ratio of the Aid flow from UN agencies (US$) in Burkina Faso in 2008 to that in 2012?
Your response must be concise. 0.42. What is the ratio of the Aid flow from UN agencies (US$) in Niger in 2008 to that in 2012?
Keep it short and to the point. 0.6. What is the ratio of the Aid flow from UN agencies (US$) of Pakistan in 2008 to that in 2012?
Ensure brevity in your answer.  0.55. What is the ratio of the Aid flow from UN agencies (US$) in Europe(developing only) in 2008 to that in 2013?
Your answer should be very brief. 0.81. What is the ratio of the Aid flow from UN agencies (US$) in Burkina Faso in 2008 to that in 2013?
Keep it short and to the point. 0.44. What is the ratio of the Aid flow from UN agencies (US$) of Niger in 2008 to that in 2013?
Offer a terse response. 0.53. What is the ratio of the Aid flow from UN agencies (US$) of Pakistan in 2008 to that in 2013?
Offer a very short reply. 0.86. What is the ratio of the Aid flow from UN agencies (US$) in Europe(developing only) in 2009 to that in 2010?
Your answer should be very brief. 0.9. What is the ratio of the Aid flow from UN agencies (US$) in Burkina Faso in 2009 to that in 2010?
Provide a short and direct response. 0.57. What is the ratio of the Aid flow from UN agencies (US$) in Niger in 2009 to that in 2010?
Make the answer very short. 0.71. What is the ratio of the Aid flow from UN agencies (US$) in Pakistan in 2009 to that in 2010?
Give a very brief answer. 1.4. What is the ratio of the Aid flow from UN agencies (US$) of Europe(developing only) in 2009 to that in 2011?
Ensure brevity in your answer.  0.7. What is the ratio of the Aid flow from UN agencies (US$) in Burkina Faso in 2009 to that in 2011?
Your answer should be very brief. 0.44. What is the ratio of the Aid flow from UN agencies (US$) of Niger in 2009 to that in 2011?
Give a very brief answer. 0.56. What is the ratio of the Aid flow from UN agencies (US$) of Pakistan in 2009 to that in 2011?
Offer a very short reply. 1.25. What is the ratio of the Aid flow from UN agencies (US$) of Europe(developing only) in 2009 to that in 2012?
Ensure brevity in your answer.  0.73. What is the ratio of the Aid flow from UN agencies (US$) of Burkina Faso in 2009 to that in 2012?
Your answer should be very brief. 0.51. What is the ratio of the Aid flow from UN agencies (US$) in Niger in 2009 to that in 2012?
Your answer should be compact. 0.74. What is the ratio of the Aid flow from UN agencies (US$) of Pakistan in 2009 to that in 2012?
Offer a very short reply. 1.11. What is the ratio of the Aid flow from UN agencies (US$) in Europe(developing only) in 2009 to that in 2013?
Offer a very short reply. 0.84. What is the ratio of the Aid flow from UN agencies (US$) in Burkina Faso in 2009 to that in 2013?
Offer a terse response. 0.54. What is the ratio of the Aid flow from UN agencies (US$) of Niger in 2009 to that in 2013?
Keep it short and to the point. 0.65. What is the ratio of the Aid flow from UN agencies (US$) in Pakistan in 2009 to that in 2013?
Your response must be concise. 1.74. What is the ratio of the Aid flow from UN agencies (US$) in Europe(developing only) in 2010 to that in 2011?
Your answer should be compact. 0.77. What is the ratio of the Aid flow from UN agencies (US$) in Burkina Faso in 2010 to that in 2011?
Keep it short and to the point. 0.77. What is the ratio of the Aid flow from UN agencies (US$) in Niger in 2010 to that in 2011?
Give a very brief answer. 0.79. What is the ratio of the Aid flow from UN agencies (US$) in Pakistan in 2010 to that in 2011?
Provide a short and direct response. 0.89. What is the ratio of the Aid flow from UN agencies (US$) in Europe(developing only) in 2010 to that in 2012?
Your answer should be compact. 0.81. What is the ratio of the Aid flow from UN agencies (US$) of Burkina Faso in 2010 to that in 2012?
Offer a terse response. 0.9. What is the ratio of the Aid flow from UN agencies (US$) in Niger in 2010 to that in 2012?
Provide a succinct answer. 1.05. What is the ratio of the Aid flow from UN agencies (US$) in Pakistan in 2010 to that in 2012?
Offer a very short reply. 0.79. What is the ratio of the Aid flow from UN agencies (US$) in Europe(developing only) in 2010 to that in 2013?
Provide a succinct answer. 0.93. What is the ratio of the Aid flow from UN agencies (US$) in Burkina Faso in 2010 to that in 2013?
Offer a very short reply. 0.95. What is the ratio of the Aid flow from UN agencies (US$) in Niger in 2010 to that in 2013?
Your answer should be very brief. 0.92. What is the ratio of the Aid flow from UN agencies (US$) of Pakistan in 2010 to that in 2013?
Your response must be concise. 1.24. What is the ratio of the Aid flow from UN agencies (US$) in Europe(developing only) in 2011 to that in 2012?
Offer a terse response. 1.04. What is the ratio of the Aid flow from UN agencies (US$) in Burkina Faso in 2011 to that in 2012?
Make the answer very short. 1.16. What is the ratio of the Aid flow from UN agencies (US$) of Niger in 2011 to that in 2012?
Ensure brevity in your answer.  1.33. What is the ratio of the Aid flow from UN agencies (US$) of Pakistan in 2011 to that in 2012?
Make the answer very short. 0.89. What is the ratio of the Aid flow from UN agencies (US$) in Europe(developing only) in 2011 to that in 2013?
Provide a succinct answer. 1.2. What is the ratio of the Aid flow from UN agencies (US$) of Burkina Faso in 2011 to that in 2013?
Your answer should be compact. 1.24. What is the ratio of the Aid flow from UN agencies (US$) of Niger in 2011 to that in 2013?
Provide a short and direct response. 1.16. What is the ratio of the Aid flow from UN agencies (US$) of Pakistan in 2011 to that in 2013?
Ensure brevity in your answer.  1.4. What is the ratio of the Aid flow from UN agencies (US$) in Europe(developing only) in 2012 to that in 2013?
Your answer should be very brief. 1.15. What is the ratio of the Aid flow from UN agencies (US$) of Burkina Faso in 2012 to that in 2013?
Ensure brevity in your answer.  1.06. What is the ratio of the Aid flow from UN agencies (US$) of Niger in 2012 to that in 2013?
Your response must be concise. 0.88. What is the ratio of the Aid flow from UN agencies (US$) in Pakistan in 2012 to that in 2013?
Offer a very short reply. 1.57. What is the difference between the highest and the second highest Aid flow from UN agencies (US$) of Burkina Faso?
Your response must be concise. 1.10e+05. What is the difference between the highest and the second highest Aid flow from UN agencies (US$) of Niger?
Provide a short and direct response. 8.00e+04. What is the difference between the highest and the lowest Aid flow from UN agencies (US$) of Europe(developing only)?
Your answer should be compact. 1.34e+06. What is the difference between the highest and the lowest Aid flow from UN agencies (US$) in Niger?
Provide a succinct answer. 3.80e+05. What is the difference between the highest and the lowest Aid flow from UN agencies (US$) of Pakistan?
Your response must be concise. 6.30e+05. 